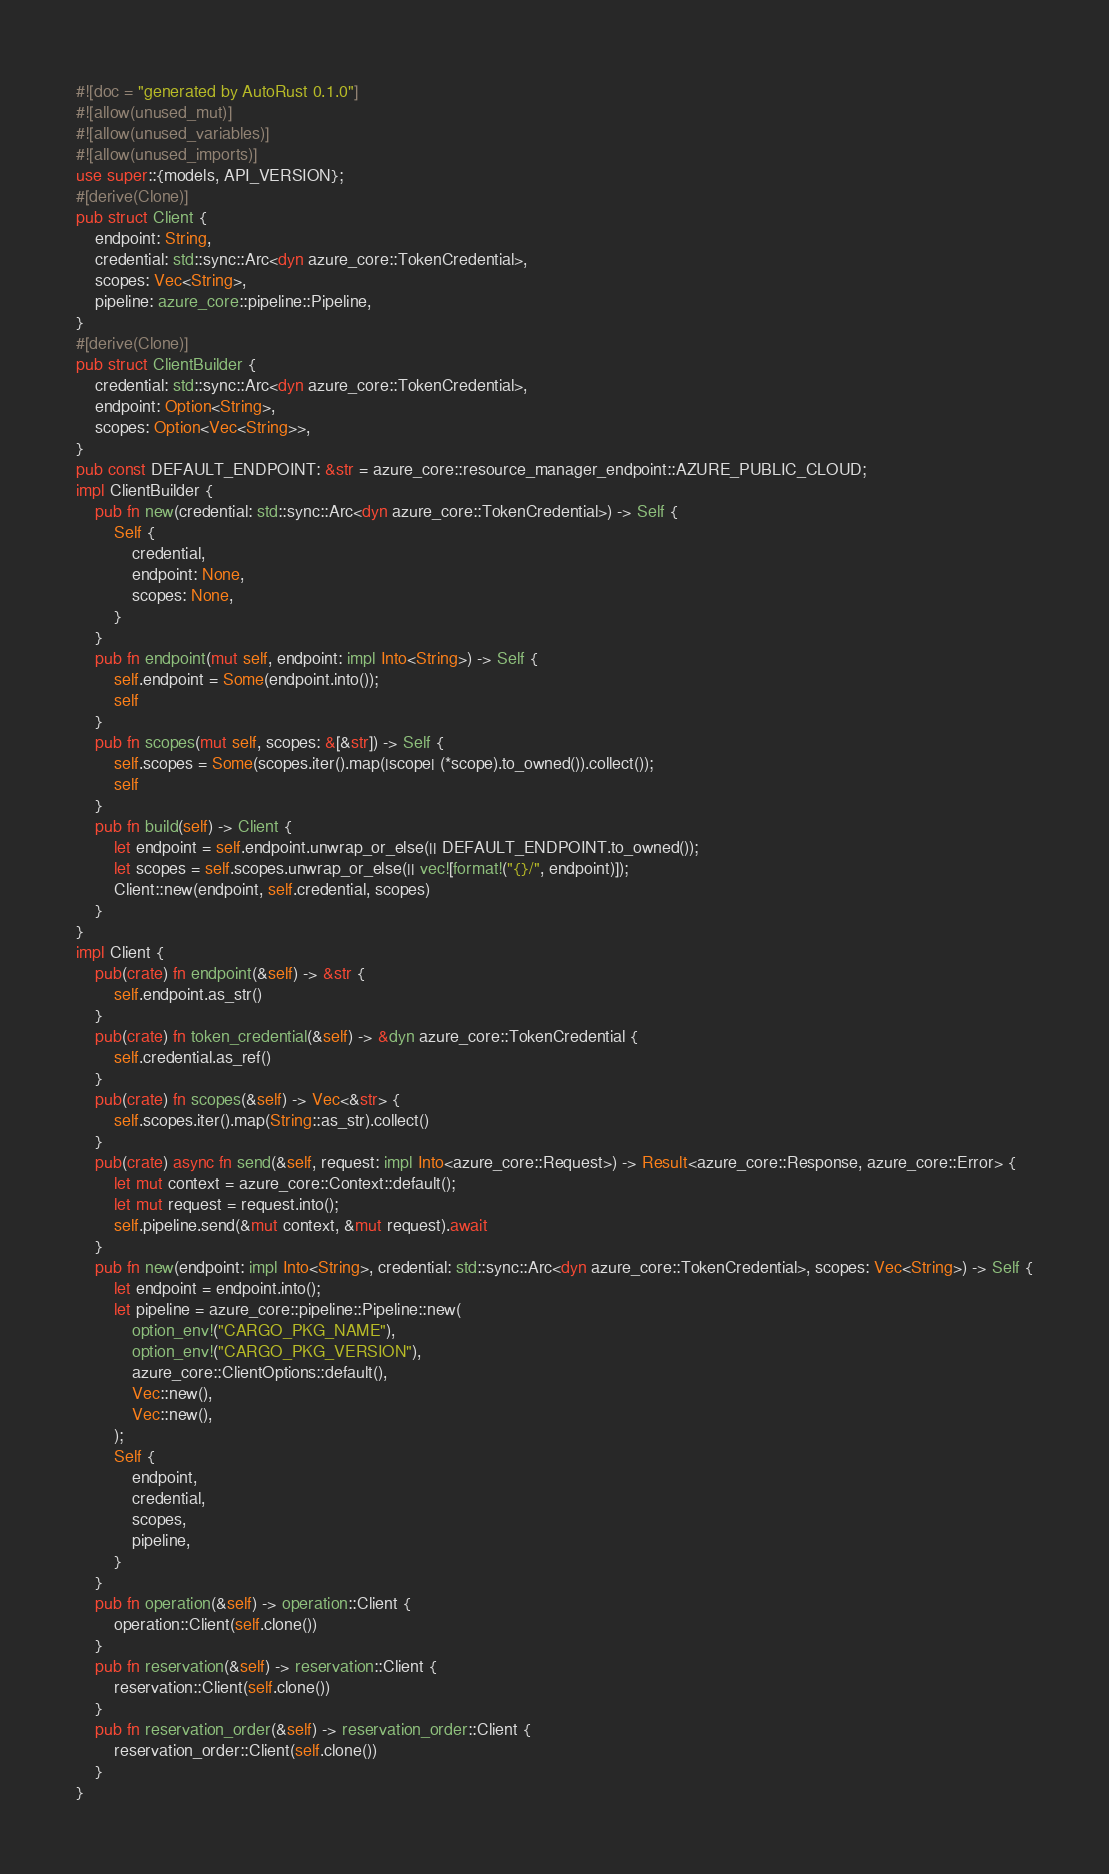Convert code to text. <code><loc_0><loc_0><loc_500><loc_500><_Rust_>#![doc = "generated by AutoRust 0.1.0"]
#![allow(unused_mut)]
#![allow(unused_variables)]
#![allow(unused_imports)]
use super::{models, API_VERSION};
#[derive(Clone)]
pub struct Client {
    endpoint: String,
    credential: std::sync::Arc<dyn azure_core::TokenCredential>,
    scopes: Vec<String>,
    pipeline: azure_core::pipeline::Pipeline,
}
#[derive(Clone)]
pub struct ClientBuilder {
    credential: std::sync::Arc<dyn azure_core::TokenCredential>,
    endpoint: Option<String>,
    scopes: Option<Vec<String>>,
}
pub const DEFAULT_ENDPOINT: &str = azure_core::resource_manager_endpoint::AZURE_PUBLIC_CLOUD;
impl ClientBuilder {
    pub fn new(credential: std::sync::Arc<dyn azure_core::TokenCredential>) -> Self {
        Self {
            credential,
            endpoint: None,
            scopes: None,
        }
    }
    pub fn endpoint(mut self, endpoint: impl Into<String>) -> Self {
        self.endpoint = Some(endpoint.into());
        self
    }
    pub fn scopes(mut self, scopes: &[&str]) -> Self {
        self.scopes = Some(scopes.iter().map(|scope| (*scope).to_owned()).collect());
        self
    }
    pub fn build(self) -> Client {
        let endpoint = self.endpoint.unwrap_or_else(|| DEFAULT_ENDPOINT.to_owned());
        let scopes = self.scopes.unwrap_or_else(|| vec![format!("{}/", endpoint)]);
        Client::new(endpoint, self.credential, scopes)
    }
}
impl Client {
    pub(crate) fn endpoint(&self) -> &str {
        self.endpoint.as_str()
    }
    pub(crate) fn token_credential(&self) -> &dyn azure_core::TokenCredential {
        self.credential.as_ref()
    }
    pub(crate) fn scopes(&self) -> Vec<&str> {
        self.scopes.iter().map(String::as_str).collect()
    }
    pub(crate) async fn send(&self, request: impl Into<azure_core::Request>) -> Result<azure_core::Response, azure_core::Error> {
        let mut context = azure_core::Context::default();
        let mut request = request.into();
        self.pipeline.send(&mut context, &mut request).await
    }
    pub fn new(endpoint: impl Into<String>, credential: std::sync::Arc<dyn azure_core::TokenCredential>, scopes: Vec<String>) -> Self {
        let endpoint = endpoint.into();
        let pipeline = azure_core::pipeline::Pipeline::new(
            option_env!("CARGO_PKG_NAME"),
            option_env!("CARGO_PKG_VERSION"),
            azure_core::ClientOptions::default(),
            Vec::new(),
            Vec::new(),
        );
        Self {
            endpoint,
            credential,
            scopes,
            pipeline,
        }
    }
    pub fn operation(&self) -> operation::Client {
        operation::Client(self.clone())
    }
    pub fn reservation(&self) -> reservation::Client {
        reservation::Client(self.clone())
    }
    pub fn reservation_order(&self) -> reservation_order::Client {
        reservation_order::Client(self.clone())
    }
}</code> 